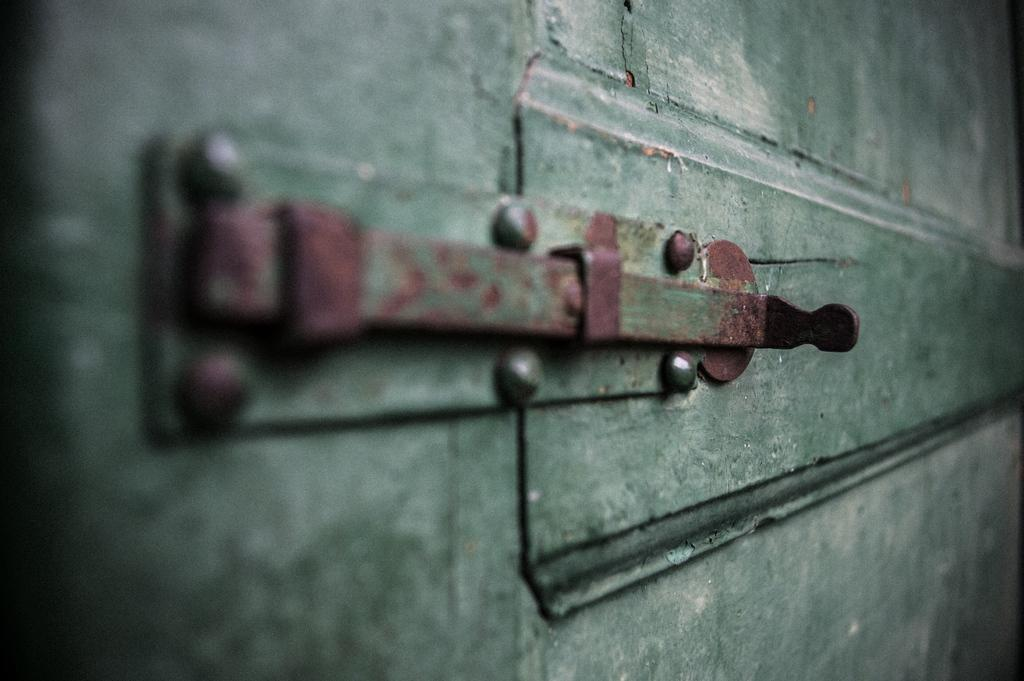What is the main subject of the image? The main subject of the image is a door airdrop. Can you describe the door in the image? There is a green door in the image. How would you describe the overall quality of the image? The image is blurred. How many hens are visible in the image? There are no hens present in the image; it features a door airdrop and a green door. What type of trucks can be seen in the image? There are no trucks present in the image. 